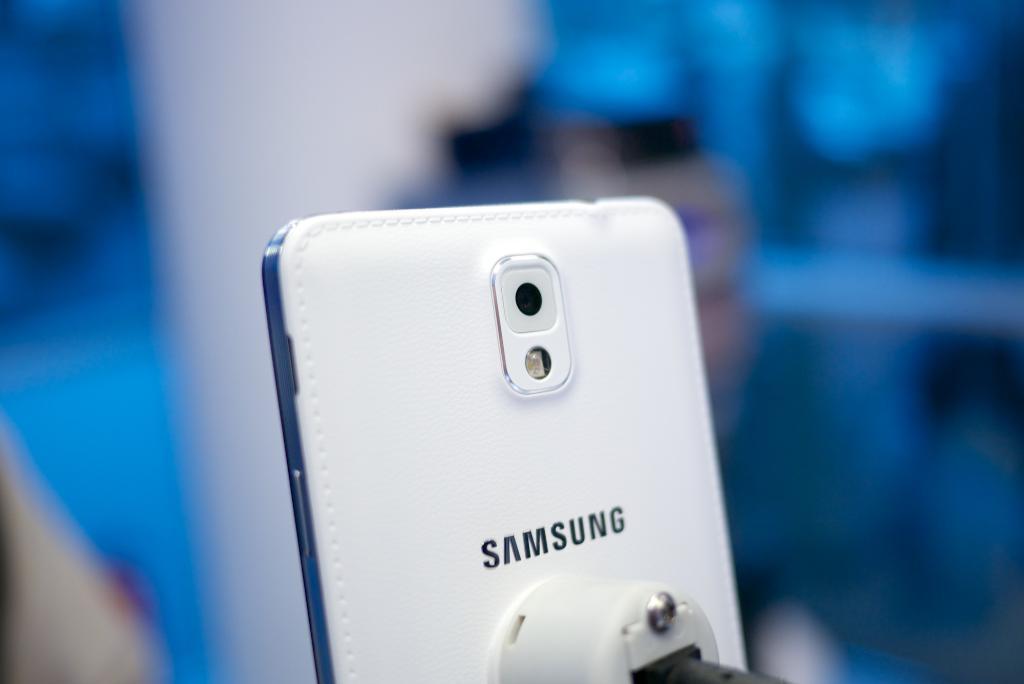What brand of phone is shown?
Provide a short and direct response. Samsung. 